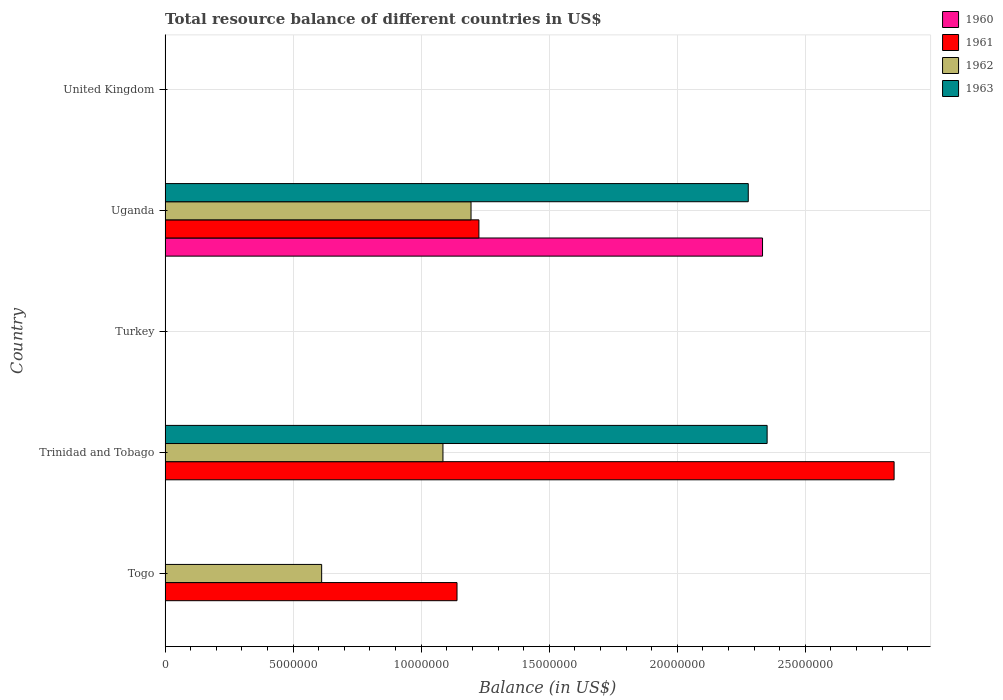How many different coloured bars are there?
Your answer should be very brief. 4. Are the number of bars on each tick of the Y-axis equal?
Your answer should be compact. No. What is the label of the 3rd group of bars from the top?
Offer a terse response. Turkey. What is the total resource balance in 1963 in Uganda?
Ensure brevity in your answer.  2.28e+07. Across all countries, what is the maximum total resource balance in 1961?
Ensure brevity in your answer.  2.85e+07. Across all countries, what is the minimum total resource balance in 1960?
Give a very brief answer. 0. In which country was the total resource balance in 1960 maximum?
Offer a terse response. Uganda. What is the total total resource balance in 1961 in the graph?
Make the answer very short. 5.21e+07. What is the difference between the total resource balance in 1962 in Togo and that in Uganda?
Offer a very short reply. -5.83e+06. What is the average total resource balance in 1962 per country?
Ensure brevity in your answer.  5.78e+06. What is the difference between the total resource balance in 1962 and total resource balance in 1961 in Trinidad and Tobago?
Give a very brief answer. -1.76e+07. In how many countries, is the total resource balance in 1960 greater than 26000000 US$?
Offer a terse response. 0. Is the difference between the total resource balance in 1962 in Togo and Uganda greater than the difference between the total resource balance in 1961 in Togo and Uganda?
Keep it short and to the point. No. What is the difference between the highest and the lowest total resource balance in 1963?
Keep it short and to the point. 2.35e+07. In how many countries, is the total resource balance in 1962 greater than the average total resource balance in 1962 taken over all countries?
Your answer should be compact. 3. Are all the bars in the graph horizontal?
Provide a succinct answer. Yes. What is the difference between two consecutive major ticks on the X-axis?
Provide a succinct answer. 5.00e+06. Does the graph contain grids?
Your response must be concise. Yes. Where does the legend appear in the graph?
Your answer should be compact. Top right. What is the title of the graph?
Provide a short and direct response. Total resource balance of different countries in US$. Does "1983" appear as one of the legend labels in the graph?
Make the answer very short. No. What is the label or title of the X-axis?
Provide a short and direct response. Balance (in US$). What is the Balance (in US$) of 1961 in Togo?
Your answer should be compact. 1.14e+07. What is the Balance (in US$) in 1962 in Togo?
Offer a terse response. 6.11e+06. What is the Balance (in US$) of 1963 in Togo?
Provide a succinct answer. 0. What is the Balance (in US$) in 1961 in Trinidad and Tobago?
Provide a succinct answer. 2.85e+07. What is the Balance (in US$) in 1962 in Trinidad and Tobago?
Your response must be concise. 1.08e+07. What is the Balance (in US$) in 1963 in Trinidad and Tobago?
Make the answer very short. 2.35e+07. What is the Balance (in US$) in 1961 in Turkey?
Make the answer very short. 0. What is the Balance (in US$) of 1960 in Uganda?
Provide a succinct answer. 2.33e+07. What is the Balance (in US$) of 1961 in Uganda?
Offer a terse response. 1.23e+07. What is the Balance (in US$) of 1962 in Uganda?
Ensure brevity in your answer.  1.19e+07. What is the Balance (in US$) in 1963 in Uganda?
Ensure brevity in your answer.  2.28e+07. What is the Balance (in US$) in 1961 in United Kingdom?
Make the answer very short. 0. Across all countries, what is the maximum Balance (in US$) of 1960?
Provide a short and direct response. 2.33e+07. Across all countries, what is the maximum Balance (in US$) of 1961?
Give a very brief answer. 2.85e+07. Across all countries, what is the maximum Balance (in US$) of 1962?
Ensure brevity in your answer.  1.19e+07. Across all countries, what is the maximum Balance (in US$) in 1963?
Your answer should be compact. 2.35e+07. What is the total Balance (in US$) of 1960 in the graph?
Keep it short and to the point. 2.33e+07. What is the total Balance (in US$) of 1961 in the graph?
Provide a succinct answer. 5.21e+07. What is the total Balance (in US$) in 1962 in the graph?
Provide a succinct answer. 2.89e+07. What is the total Balance (in US$) in 1963 in the graph?
Give a very brief answer. 4.63e+07. What is the difference between the Balance (in US$) in 1961 in Togo and that in Trinidad and Tobago?
Make the answer very short. -1.71e+07. What is the difference between the Balance (in US$) in 1962 in Togo and that in Trinidad and Tobago?
Keep it short and to the point. -4.74e+06. What is the difference between the Balance (in US$) in 1961 in Togo and that in Uganda?
Ensure brevity in your answer.  -8.54e+05. What is the difference between the Balance (in US$) of 1962 in Togo and that in Uganda?
Offer a very short reply. -5.83e+06. What is the difference between the Balance (in US$) of 1961 in Trinidad and Tobago and that in Uganda?
Ensure brevity in your answer.  1.62e+07. What is the difference between the Balance (in US$) of 1962 in Trinidad and Tobago and that in Uganda?
Provide a succinct answer. -1.10e+06. What is the difference between the Balance (in US$) in 1963 in Trinidad and Tobago and that in Uganda?
Your answer should be compact. 7.36e+05. What is the difference between the Balance (in US$) of 1961 in Togo and the Balance (in US$) of 1962 in Trinidad and Tobago?
Make the answer very short. 5.50e+05. What is the difference between the Balance (in US$) in 1961 in Togo and the Balance (in US$) in 1963 in Trinidad and Tobago?
Provide a short and direct response. -1.21e+07. What is the difference between the Balance (in US$) in 1962 in Togo and the Balance (in US$) in 1963 in Trinidad and Tobago?
Keep it short and to the point. -1.74e+07. What is the difference between the Balance (in US$) of 1961 in Togo and the Balance (in US$) of 1962 in Uganda?
Provide a short and direct response. -5.47e+05. What is the difference between the Balance (in US$) in 1961 in Togo and the Balance (in US$) in 1963 in Uganda?
Make the answer very short. -1.14e+07. What is the difference between the Balance (in US$) in 1962 in Togo and the Balance (in US$) in 1963 in Uganda?
Make the answer very short. -1.67e+07. What is the difference between the Balance (in US$) of 1961 in Trinidad and Tobago and the Balance (in US$) of 1962 in Uganda?
Your answer should be very brief. 1.65e+07. What is the difference between the Balance (in US$) of 1961 in Trinidad and Tobago and the Balance (in US$) of 1963 in Uganda?
Offer a very short reply. 5.69e+06. What is the difference between the Balance (in US$) of 1962 in Trinidad and Tobago and the Balance (in US$) of 1963 in Uganda?
Ensure brevity in your answer.  -1.19e+07. What is the average Balance (in US$) of 1960 per country?
Make the answer very short. 4.67e+06. What is the average Balance (in US$) in 1961 per country?
Your answer should be compact. 1.04e+07. What is the average Balance (in US$) of 1962 per country?
Your answer should be compact. 5.78e+06. What is the average Balance (in US$) of 1963 per country?
Your answer should be very brief. 9.26e+06. What is the difference between the Balance (in US$) of 1961 and Balance (in US$) of 1962 in Togo?
Keep it short and to the point. 5.29e+06. What is the difference between the Balance (in US$) of 1961 and Balance (in US$) of 1962 in Trinidad and Tobago?
Provide a succinct answer. 1.76e+07. What is the difference between the Balance (in US$) of 1961 and Balance (in US$) of 1963 in Trinidad and Tobago?
Your answer should be very brief. 4.96e+06. What is the difference between the Balance (in US$) of 1962 and Balance (in US$) of 1963 in Trinidad and Tobago?
Your answer should be compact. -1.27e+07. What is the difference between the Balance (in US$) of 1960 and Balance (in US$) of 1961 in Uganda?
Give a very brief answer. 1.11e+07. What is the difference between the Balance (in US$) in 1960 and Balance (in US$) in 1962 in Uganda?
Your answer should be compact. 1.14e+07. What is the difference between the Balance (in US$) in 1960 and Balance (in US$) in 1963 in Uganda?
Your answer should be very brief. 5.57e+05. What is the difference between the Balance (in US$) of 1961 and Balance (in US$) of 1962 in Uganda?
Make the answer very short. 3.07e+05. What is the difference between the Balance (in US$) in 1961 and Balance (in US$) in 1963 in Uganda?
Provide a short and direct response. -1.05e+07. What is the difference between the Balance (in US$) in 1962 and Balance (in US$) in 1963 in Uganda?
Your response must be concise. -1.08e+07. What is the ratio of the Balance (in US$) of 1961 in Togo to that in Trinidad and Tobago?
Your response must be concise. 0.4. What is the ratio of the Balance (in US$) in 1962 in Togo to that in Trinidad and Tobago?
Offer a terse response. 0.56. What is the ratio of the Balance (in US$) in 1961 in Togo to that in Uganda?
Offer a terse response. 0.93. What is the ratio of the Balance (in US$) of 1962 in Togo to that in Uganda?
Your answer should be compact. 0.51. What is the ratio of the Balance (in US$) in 1961 in Trinidad and Tobago to that in Uganda?
Make the answer very short. 2.32. What is the ratio of the Balance (in US$) in 1962 in Trinidad and Tobago to that in Uganda?
Provide a short and direct response. 0.91. What is the ratio of the Balance (in US$) of 1963 in Trinidad and Tobago to that in Uganda?
Provide a succinct answer. 1.03. What is the difference between the highest and the second highest Balance (in US$) of 1961?
Offer a very short reply. 1.62e+07. What is the difference between the highest and the second highest Balance (in US$) in 1962?
Offer a very short reply. 1.10e+06. What is the difference between the highest and the lowest Balance (in US$) in 1960?
Make the answer very short. 2.33e+07. What is the difference between the highest and the lowest Balance (in US$) in 1961?
Give a very brief answer. 2.85e+07. What is the difference between the highest and the lowest Balance (in US$) of 1962?
Keep it short and to the point. 1.19e+07. What is the difference between the highest and the lowest Balance (in US$) of 1963?
Offer a terse response. 2.35e+07. 